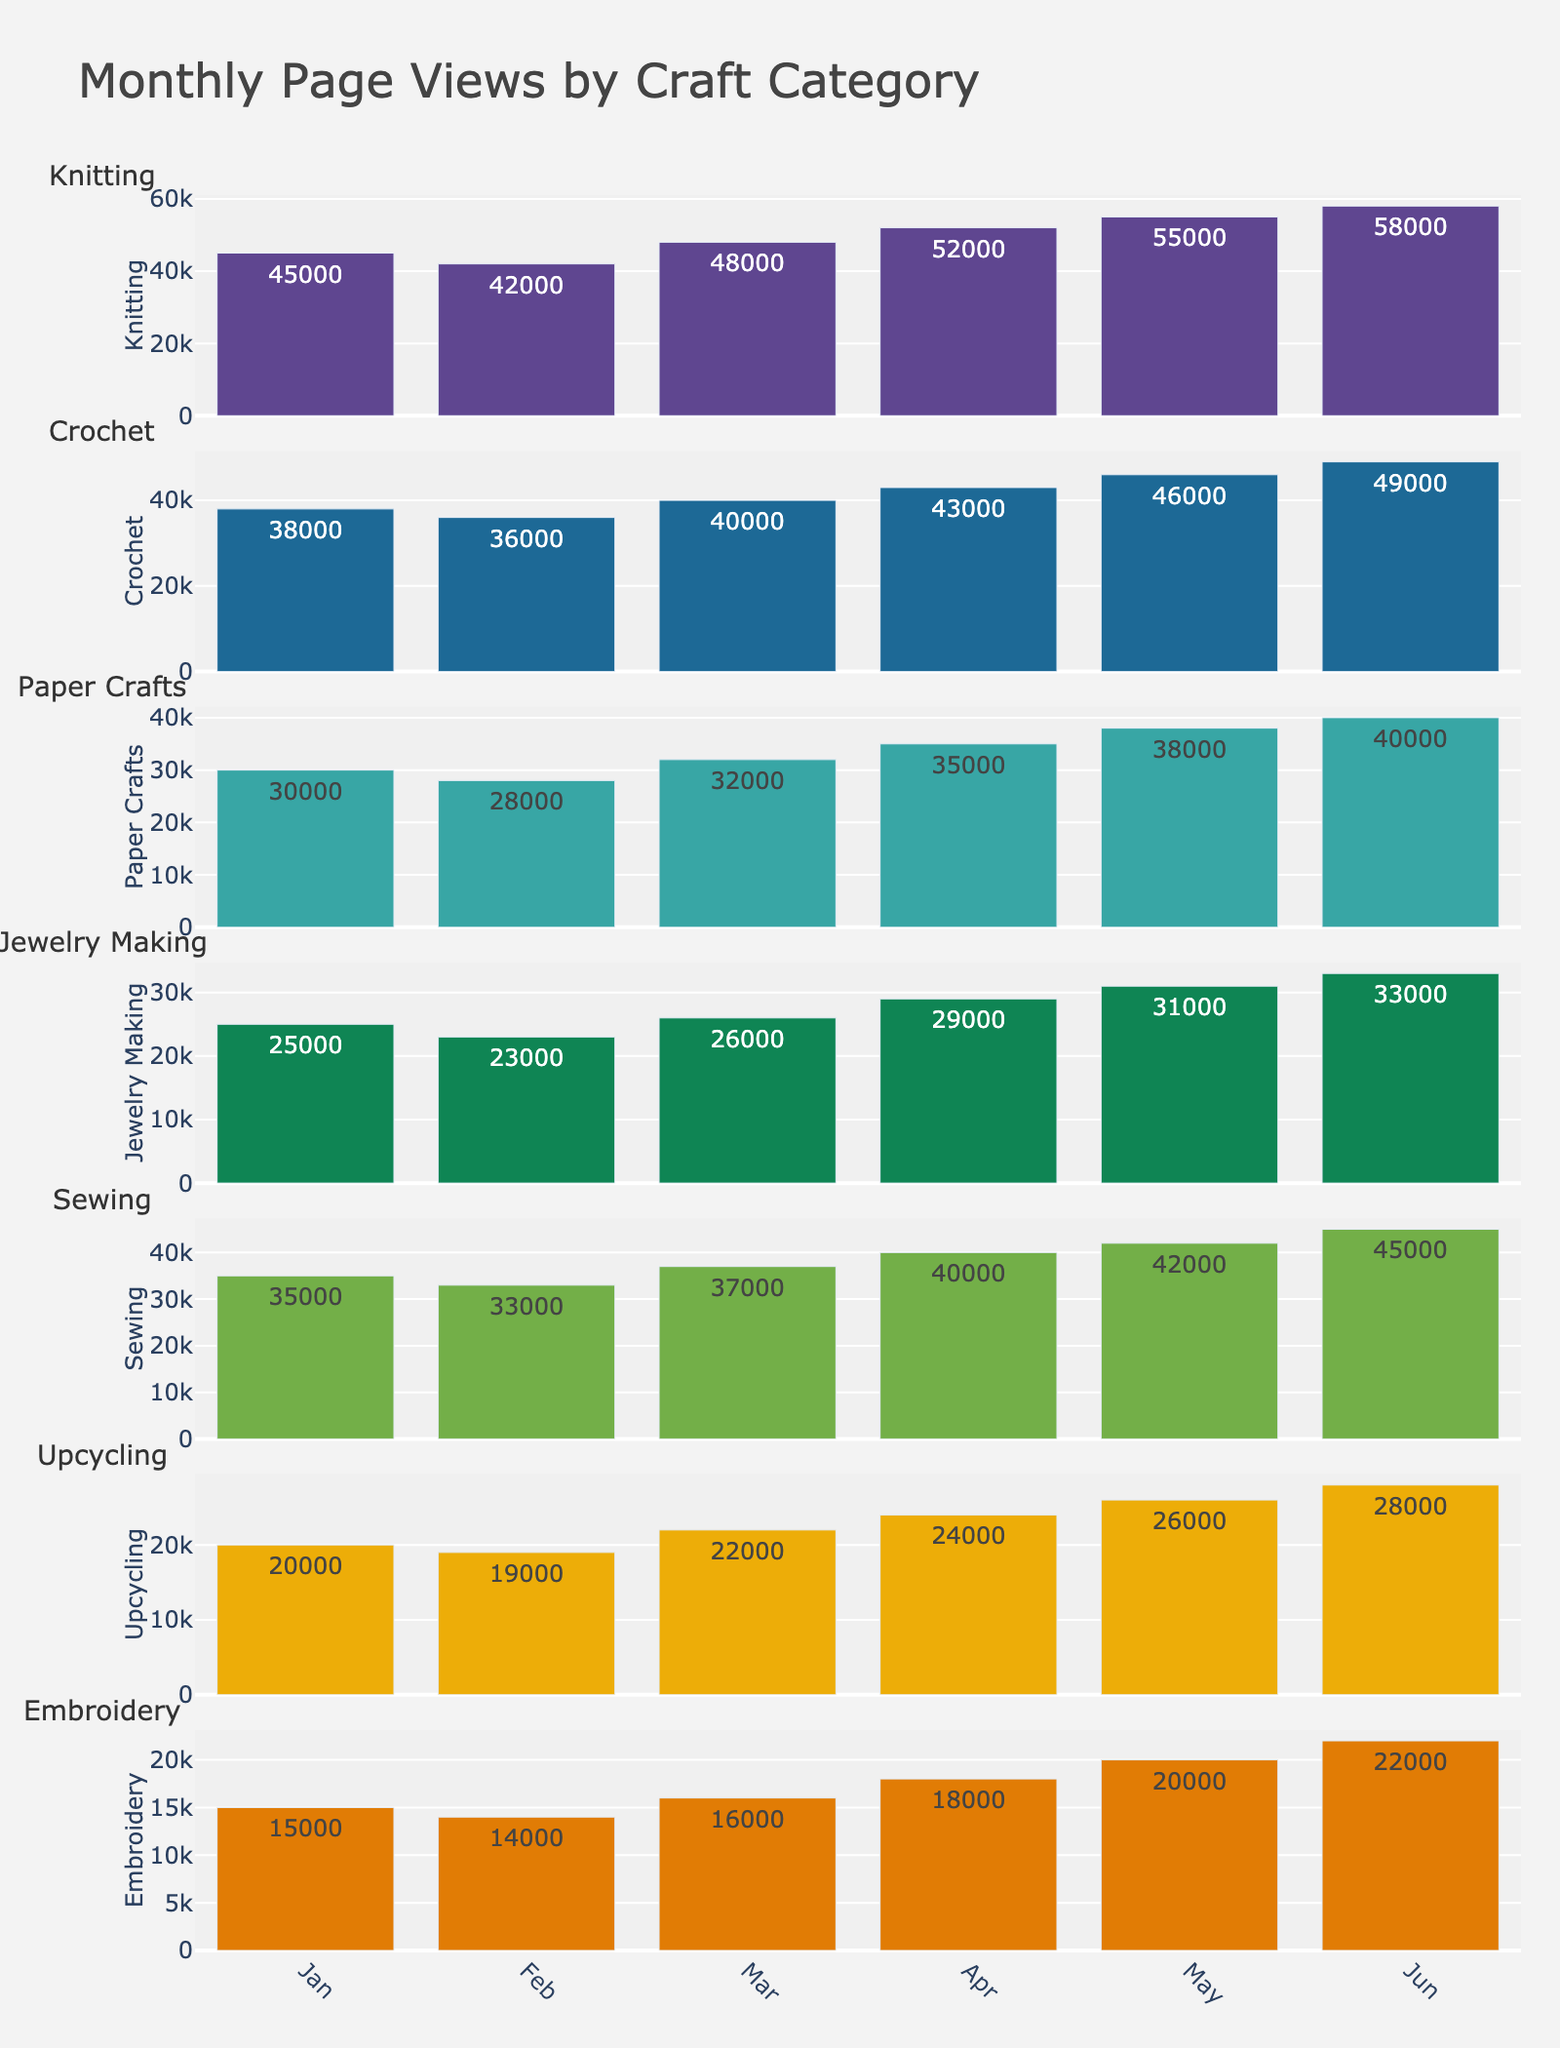What's the total page views for Knitting from Jan to Jun? To find the total page views for Knitting, sum up the monthly values: 45,000 (Jan) + 42,000 (Feb) + 48,000 (Mar) + 52,000 (Apr) + 55,000 (May) + 58,000 (Jun) = 300,000.
Answer: 300,000 Which category has the highest number of page views in May? By looking at the May bars, Knitting has the highest value of 55,000 among all categories.
Answer: Knitting What's the difference in page views between Sewing and Crochet in April? Sewing has 40,000 views and Crochet has 43,000 views in April. The difference is 40,000 - 43,000 = -3,000.
Answer: -3,000 How does the page view trend for Upcycling compare to Embroidery from Jan to Jun? Both categories have a gradually increasing trend, but Upcycling starts higher at 20,000 and reaches 28,000 in June, while Embroidery starts at 15,000 and goes up to 22,000.
Answer: Both increase, Upcycling higher What's the average page views for Paper Crafts over the six months? Add up the monthly views for Paper Crafts: 30,000 + 28,000 + 32,000 + 35,000 + 38,000 + 40,000 = 203,000. Divide by 6: 203,000 / 6 ≈ 33,833.
Answer: 33,833 Which month shows the lowest page views for Jewelry Making, and what is that value? The lowest bar for Jewelry Making is in Feb with a value of 23,000.
Answer: Feb, 23,000 Are there any months where Embroidery's page views match or exceed Sewing's? No, Embroidery's page views are consistently lower than Sewing's across all months.
Answer: No By what percentage did the Crochet page views increase from Jan to Jun? January views are 38,000 and June views are 49,000. The increase is 49,000 - 38,000 = 11,000. The percentage increase is (11,000 / 38,000) * 100 ≈ 28.95%.
Answer: 28.95% Which category had the smallest increase in page views from Jan to Jun? Embroidery increased from 15,000 to 22,000, which is a difference of 7,000. This is the smallest increase among all categories.
Answer: Embroidery 